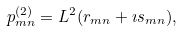Convert formula to latex. <formula><loc_0><loc_0><loc_500><loc_500>p _ { m n } ^ { ( 2 ) } = L ^ { 2 } ( r _ { m n } + \imath s _ { m n } ) ,</formula> 